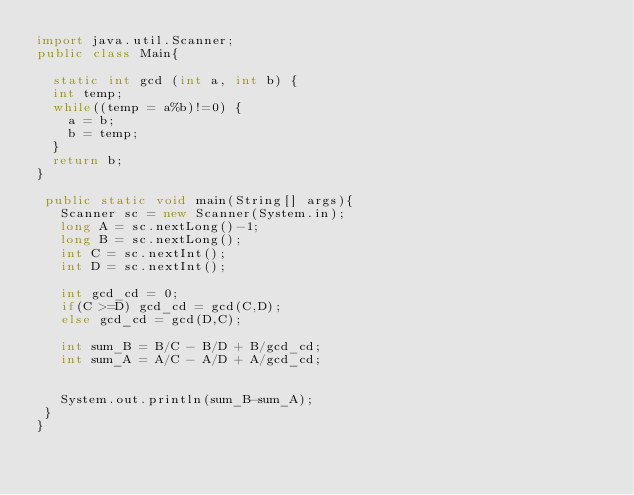Convert code to text. <code><loc_0><loc_0><loc_500><loc_500><_Java_>import java.util.Scanner;
public class Main{
 
  static int gcd (int a, int b) {
	int temp;
	while((temp = a%b)!=0) {
		a = b;
		b = temp;
	}
	return b;
}
  
 public static void main(String[] args){
   Scanner sc = new Scanner(System.in);
   long A = sc.nextLong()-1;
   long B = sc.nextLong();
   int C = sc.nextInt();
   int D = sc.nextInt();
   
   int gcd_cd = 0;
   if(C >=D) gcd_cd = gcd(C,D);
   else gcd_cd = gcd(D,C);
   
   int sum_B = B/C - B/D + B/gcd_cd;
   int sum_A = A/C - A/D + A/gcd_cd;
   
     
   System.out.println(sum_B-sum_A);
 }
}</code> 